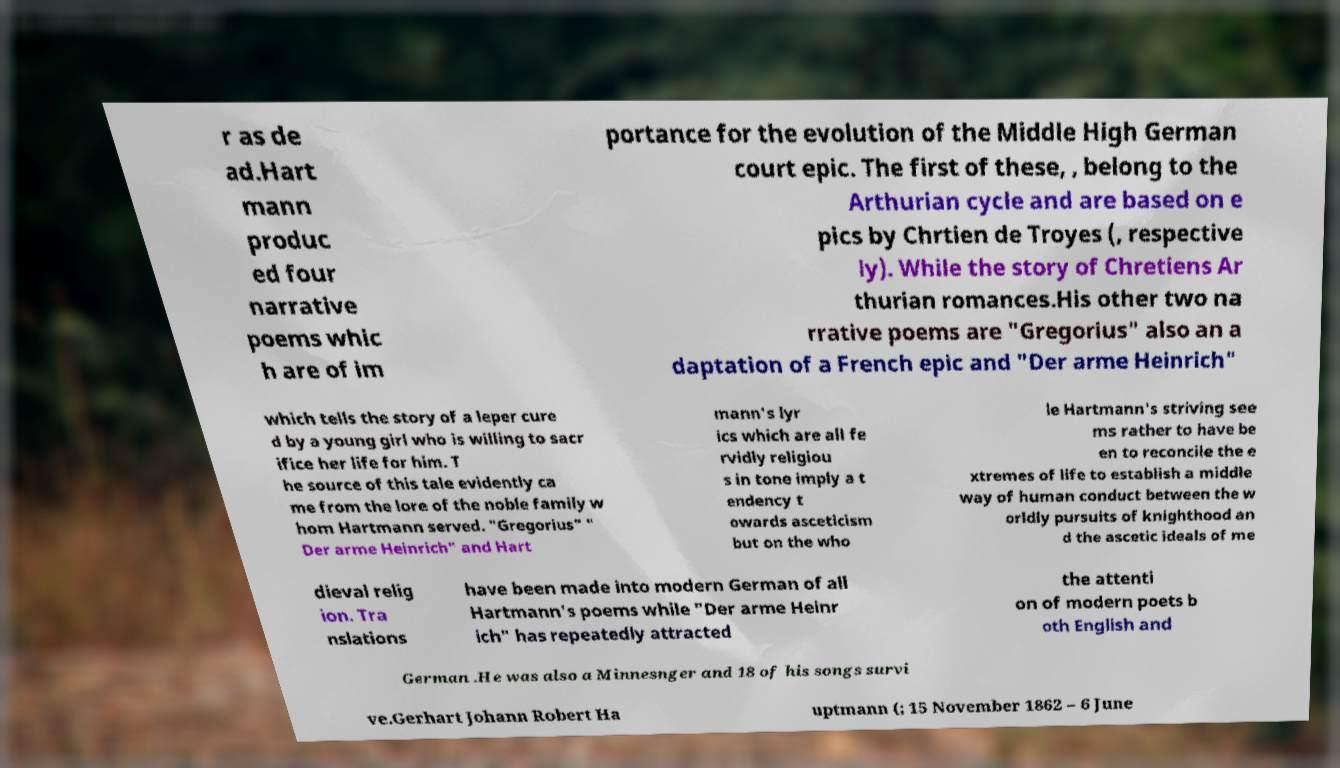Could you extract and type out the text from this image? r as de ad.Hart mann produc ed four narrative poems whic h are of im portance for the evolution of the Middle High German court epic. The first of these, , belong to the Arthurian cycle and are based on e pics by Chrtien de Troyes (, respective ly). While the story of Chretiens Ar thurian romances.His other two na rrative poems are "Gregorius" also an a daptation of a French epic and "Der arme Heinrich" which tells the story of a leper cure d by a young girl who is willing to sacr ifice her life for him. T he source of this tale evidently ca me from the lore of the noble family w hom Hartmann served. "Gregorius" " Der arme Heinrich" and Hart mann's lyr ics which are all fe rvidly religiou s in tone imply a t endency t owards asceticism but on the who le Hartmann's striving see ms rather to have be en to reconcile the e xtremes of life to establish a middle way of human conduct between the w orldly pursuits of knighthood an d the ascetic ideals of me dieval relig ion. Tra nslations have been made into modern German of all Hartmann's poems while "Der arme Heinr ich" has repeatedly attracted the attenti on of modern poets b oth English and German .He was also a Minnesnger and 18 of his songs survi ve.Gerhart Johann Robert Ha uptmann (; 15 November 1862 – 6 June 